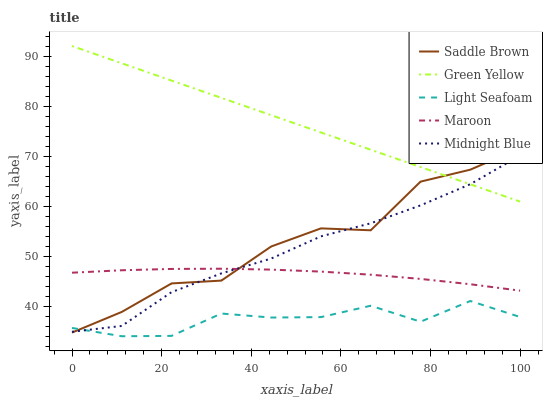Does Light Seafoam have the minimum area under the curve?
Answer yes or no. Yes. Does Green Yellow have the maximum area under the curve?
Answer yes or no. Yes. Does Saddle Brown have the minimum area under the curve?
Answer yes or no. No. Does Saddle Brown have the maximum area under the curve?
Answer yes or no. No. Is Green Yellow the smoothest?
Answer yes or no. Yes. Is Saddle Brown the roughest?
Answer yes or no. Yes. Is Saddle Brown the smoothest?
Answer yes or no. No. Is Green Yellow the roughest?
Answer yes or no. No. Does Light Seafoam have the lowest value?
Answer yes or no. Yes. Does Saddle Brown have the lowest value?
Answer yes or no. No. Does Green Yellow have the highest value?
Answer yes or no. Yes. Does Saddle Brown have the highest value?
Answer yes or no. No. Is Maroon less than Green Yellow?
Answer yes or no. Yes. Is Green Yellow greater than Light Seafoam?
Answer yes or no. Yes. Does Midnight Blue intersect Green Yellow?
Answer yes or no. Yes. Is Midnight Blue less than Green Yellow?
Answer yes or no. No. Is Midnight Blue greater than Green Yellow?
Answer yes or no. No. Does Maroon intersect Green Yellow?
Answer yes or no. No. 